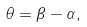Convert formula to latex. <formula><loc_0><loc_0><loc_500><loc_500>\theta = \beta - \alpha ,</formula> 